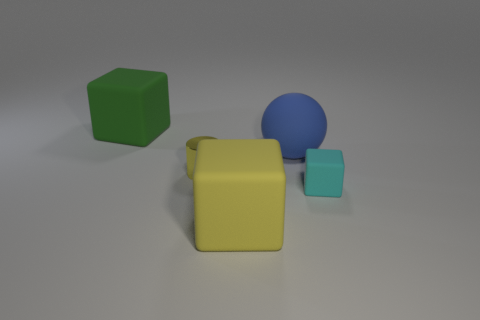Subtract all big yellow rubber cubes. How many cubes are left? 2 Subtract all green blocks. How many blocks are left? 2 Subtract 1 cylinders. How many cylinders are left? 0 Add 5 large blue balls. How many objects exist? 10 Subtract all cubes. How many objects are left? 2 Subtract all purple balls. How many gray cylinders are left? 0 Subtract all tiny rubber cubes. Subtract all metallic things. How many objects are left? 3 Add 5 metal cylinders. How many metal cylinders are left? 6 Add 4 tiny green metallic things. How many tiny green metallic things exist? 4 Subtract 1 yellow cubes. How many objects are left? 4 